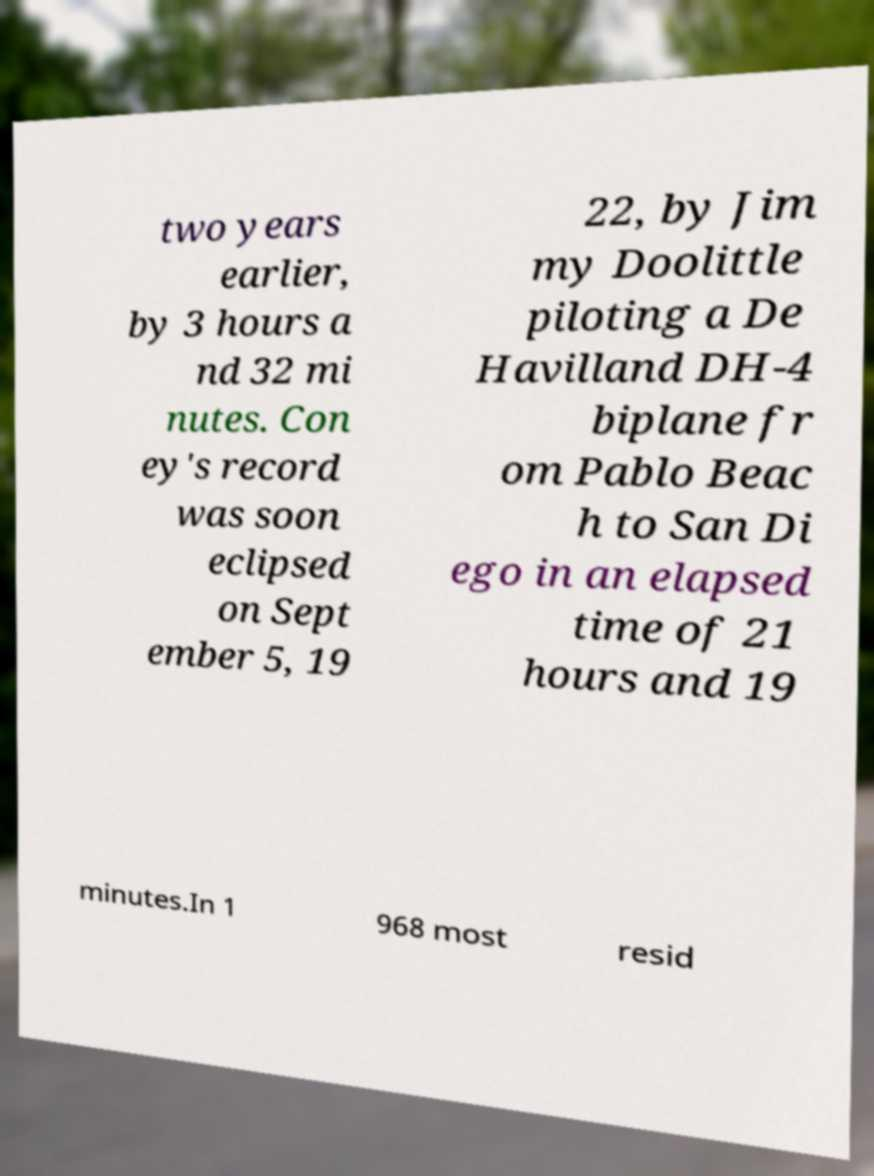Could you extract and type out the text from this image? two years earlier, by 3 hours a nd 32 mi nutes. Con ey's record was soon eclipsed on Sept ember 5, 19 22, by Jim my Doolittle piloting a De Havilland DH-4 biplane fr om Pablo Beac h to San Di ego in an elapsed time of 21 hours and 19 minutes.In 1 968 most resid 